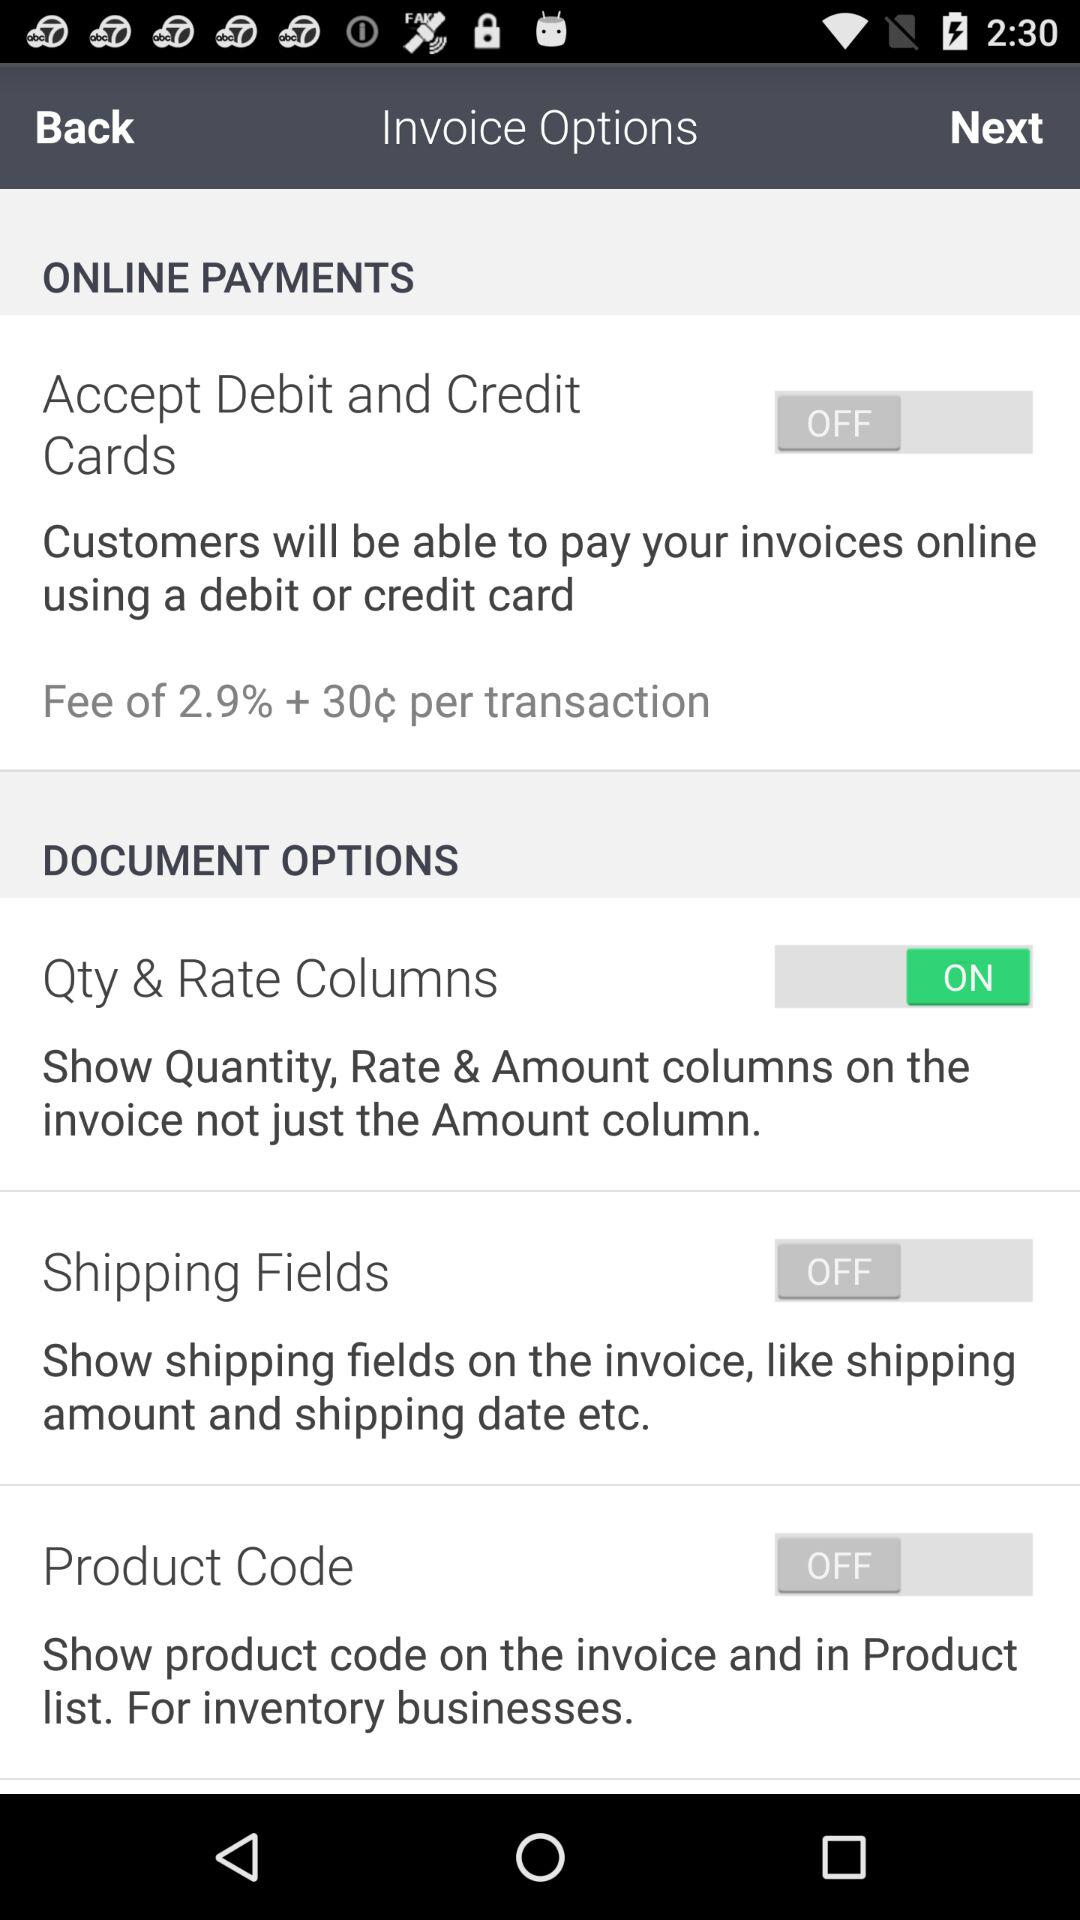Shipping fields status is on or off? The status is off. 